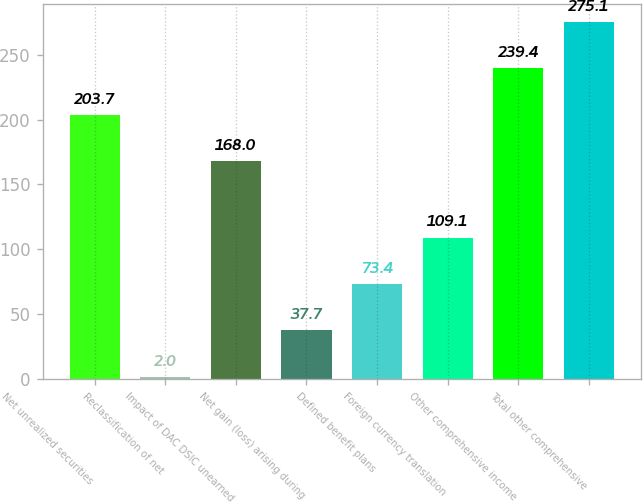<chart> <loc_0><loc_0><loc_500><loc_500><bar_chart><fcel>Net unrealized securities<fcel>Reclassification of net<fcel>Impact of DAC DSIC unearned<fcel>Net gain (loss) arising during<fcel>Defined benefit plans<fcel>Foreign currency translation<fcel>Other comprehensive income<fcel>Total other comprehensive<nl><fcel>203.7<fcel>2<fcel>168<fcel>37.7<fcel>73.4<fcel>109.1<fcel>239.4<fcel>275.1<nl></chart> 